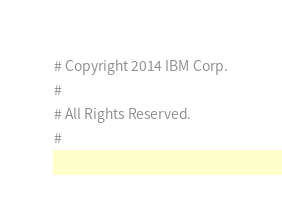Convert code to text. <code><loc_0><loc_0><loc_500><loc_500><_Python_># Copyright 2014 IBM Corp.
#
# All Rights Reserved.
#</code> 